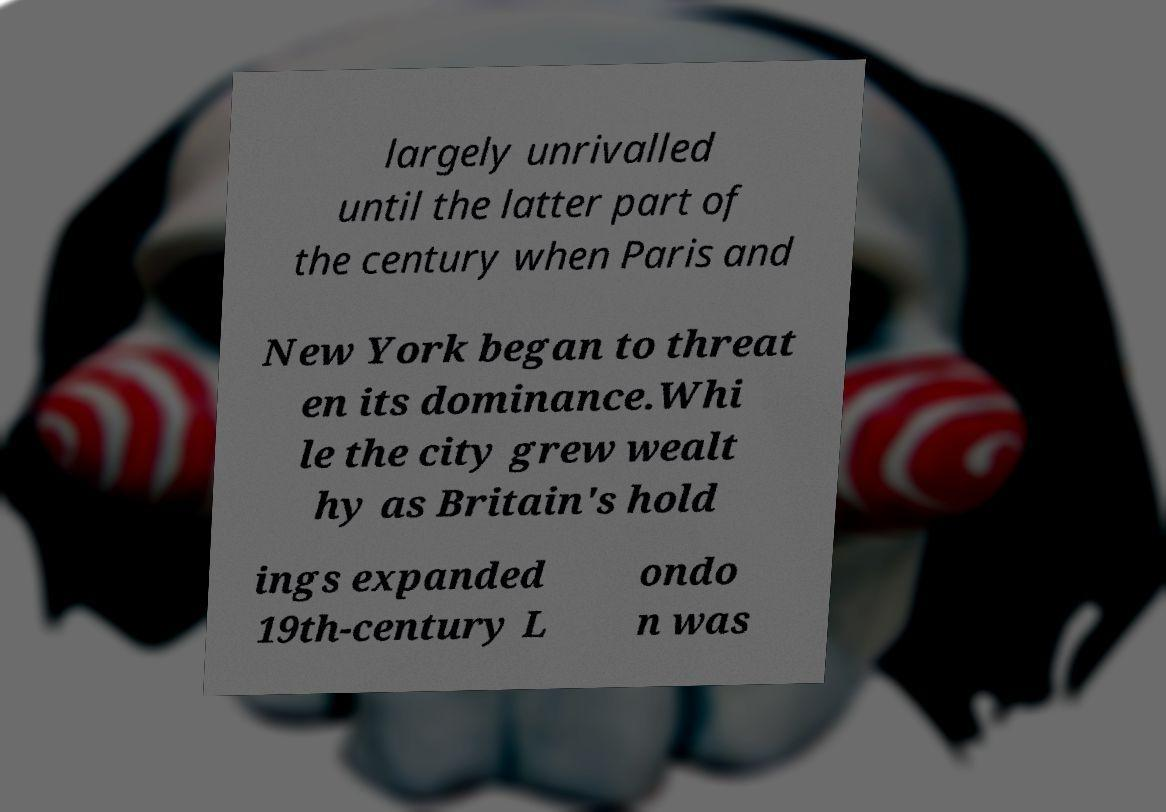What messages or text are displayed in this image? I need them in a readable, typed format. largely unrivalled until the latter part of the century when Paris and New York began to threat en its dominance.Whi le the city grew wealt hy as Britain's hold ings expanded 19th-century L ondo n was 